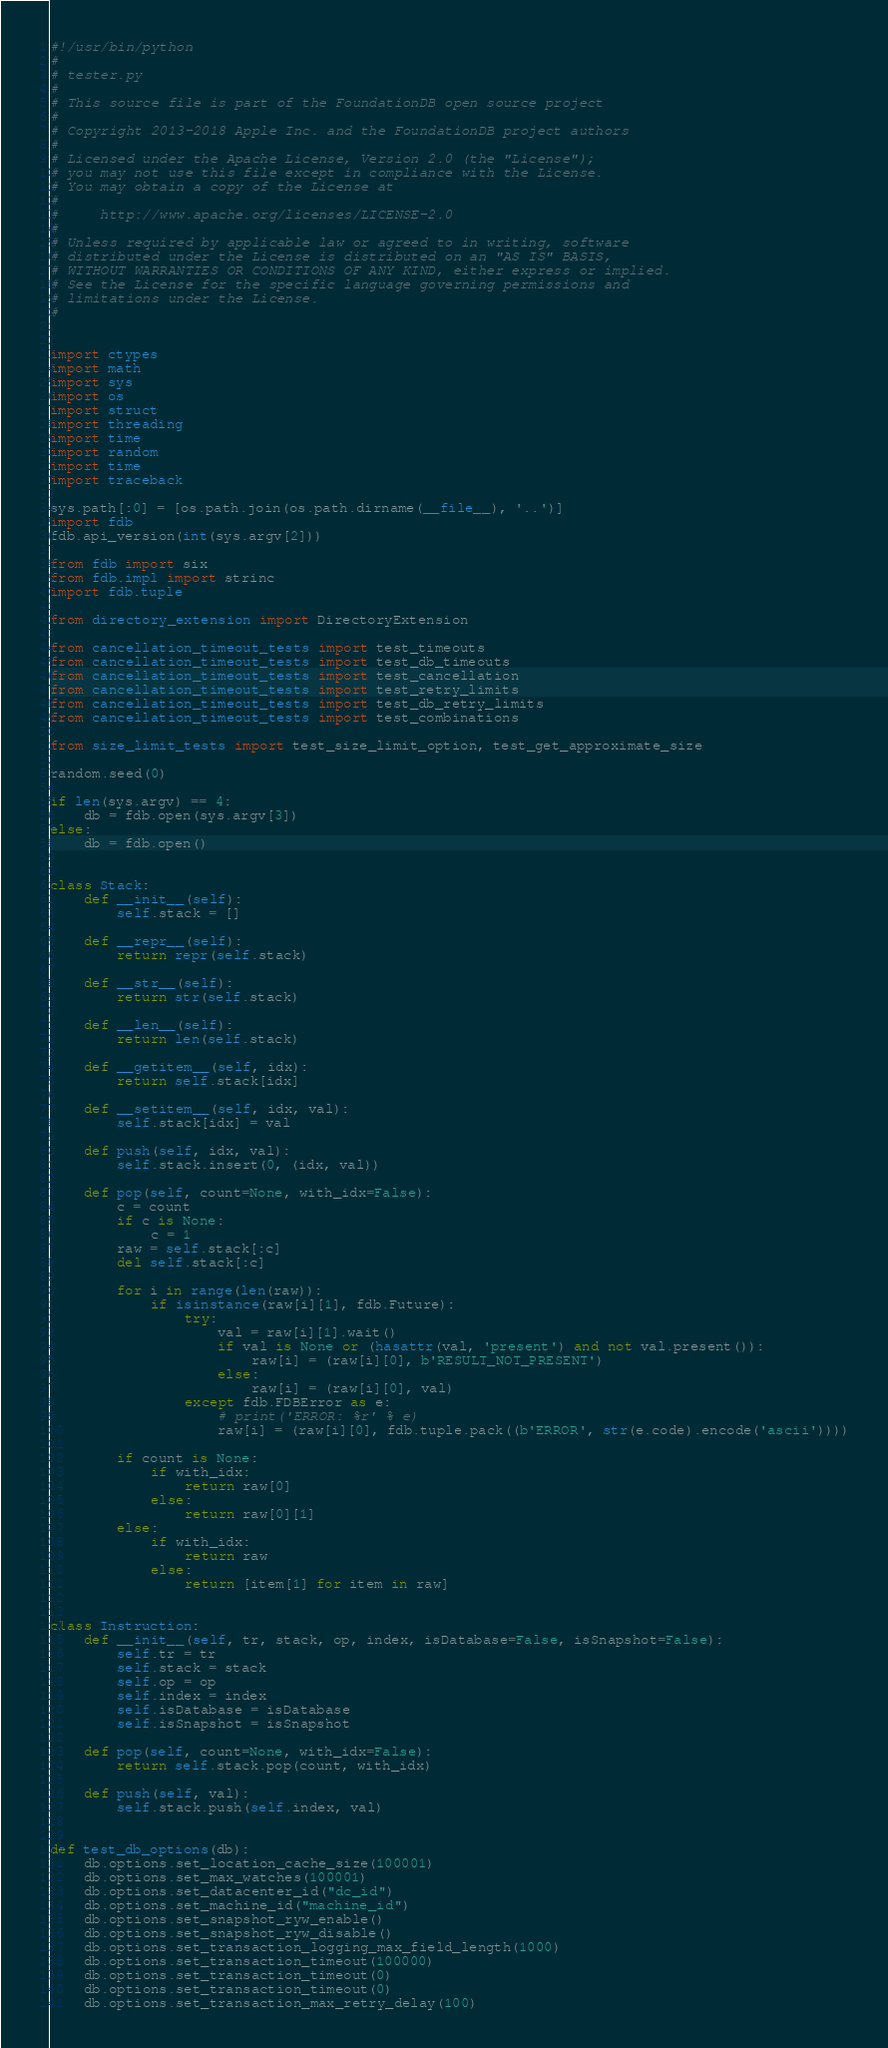Convert code to text. <code><loc_0><loc_0><loc_500><loc_500><_Python_>#!/usr/bin/python
#
# tester.py
#
# This source file is part of the FoundationDB open source project
#
# Copyright 2013-2018 Apple Inc. and the FoundationDB project authors
#
# Licensed under the Apache License, Version 2.0 (the "License");
# you may not use this file except in compliance with the License.
# You may obtain a copy of the License at
#
#     http://www.apache.org/licenses/LICENSE-2.0
#
# Unless required by applicable law or agreed to in writing, software
# distributed under the License is distributed on an "AS IS" BASIS,
# WITHOUT WARRANTIES OR CONDITIONS OF ANY KIND, either express or implied.
# See the License for the specific language governing permissions and
# limitations under the License.
#


import ctypes
import math
import sys
import os
import struct
import threading
import time
import random
import time
import traceback

sys.path[:0] = [os.path.join(os.path.dirname(__file__), '..')]
import fdb
fdb.api_version(int(sys.argv[2]))

from fdb import six
from fdb.impl import strinc
import fdb.tuple

from directory_extension import DirectoryExtension

from cancellation_timeout_tests import test_timeouts
from cancellation_timeout_tests import test_db_timeouts
from cancellation_timeout_tests import test_cancellation
from cancellation_timeout_tests import test_retry_limits
from cancellation_timeout_tests import test_db_retry_limits
from cancellation_timeout_tests import test_combinations

from size_limit_tests import test_size_limit_option, test_get_approximate_size

random.seed(0)

if len(sys.argv) == 4:
    db = fdb.open(sys.argv[3])
else:
    db = fdb.open()


class Stack:
    def __init__(self):
        self.stack = []

    def __repr__(self):
        return repr(self.stack)

    def __str__(self):
        return str(self.stack)

    def __len__(self):
        return len(self.stack)

    def __getitem__(self, idx):
        return self.stack[idx]

    def __setitem__(self, idx, val):
        self.stack[idx] = val

    def push(self, idx, val):
        self.stack.insert(0, (idx, val))

    def pop(self, count=None, with_idx=False):
        c = count
        if c is None:
            c = 1
        raw = self.stack[:c]
        del self.stack[:c]

        for i in range(len(raw)):
            if isinstance(raw[i][1], fdb.Future):
                try:
                    val = raw[i][1].wait()
                    if val is None or (hasattr(val, 'present') and not val.present()):
                        raw[i] = (raw[i][0], b'RESULT_NOT_PRESENT')
                    else:
                        raw[i] = (raw[i][0], val)
                except fdb.FDBError as e:
                    # print('ERROR: %r' % e)
                    raw[i] = (raw[i][0], fdb.tuple.pack((b'ERROR', str(e.code).encode('ascii'))))

        if count is None:
            if with_idx:
                return raw[0]
            else:
                return raw[0][1]
        else:
            if with_idx:
                return raw
            else:
                return [item[1] for item in raw]


class Instruction:
    def __init__(self, tr, stack, op, index, isDatabase=False, isSnapshot=False):
        self.tr = tr
        self.stack = stack
        self.op = op
        self.index = index
        self.isDatabase = isDatabase
        self.isSnapshot = isSnapshot

    def pop(self, count=None, with_idx=False):
        return self.stack.pop(count, with_idx)

    def push(self, val):
        self.stack.push(self.index, val)


def test_db_options(db):
    db.options.set_location_cache_size(100001)
    db.options.set_max_watches(100001)
    db.options.set_datacenter_id("dc_id")
    db.options.set_machine_id("machine_id")
    db.options.set_snapshot_ryw_enable()
    db.options.set_snapshot_ryw_disable()
    db.options.set_transaction_logging_max_field_length(1000)
    db.options.set_transaction_timeout(100000)
    db.options.set_transaction_timeout(0)
    db.options.set_transaction_timeout(0)
    db.options.set_transaction_max_retry_delay(100)</code> 